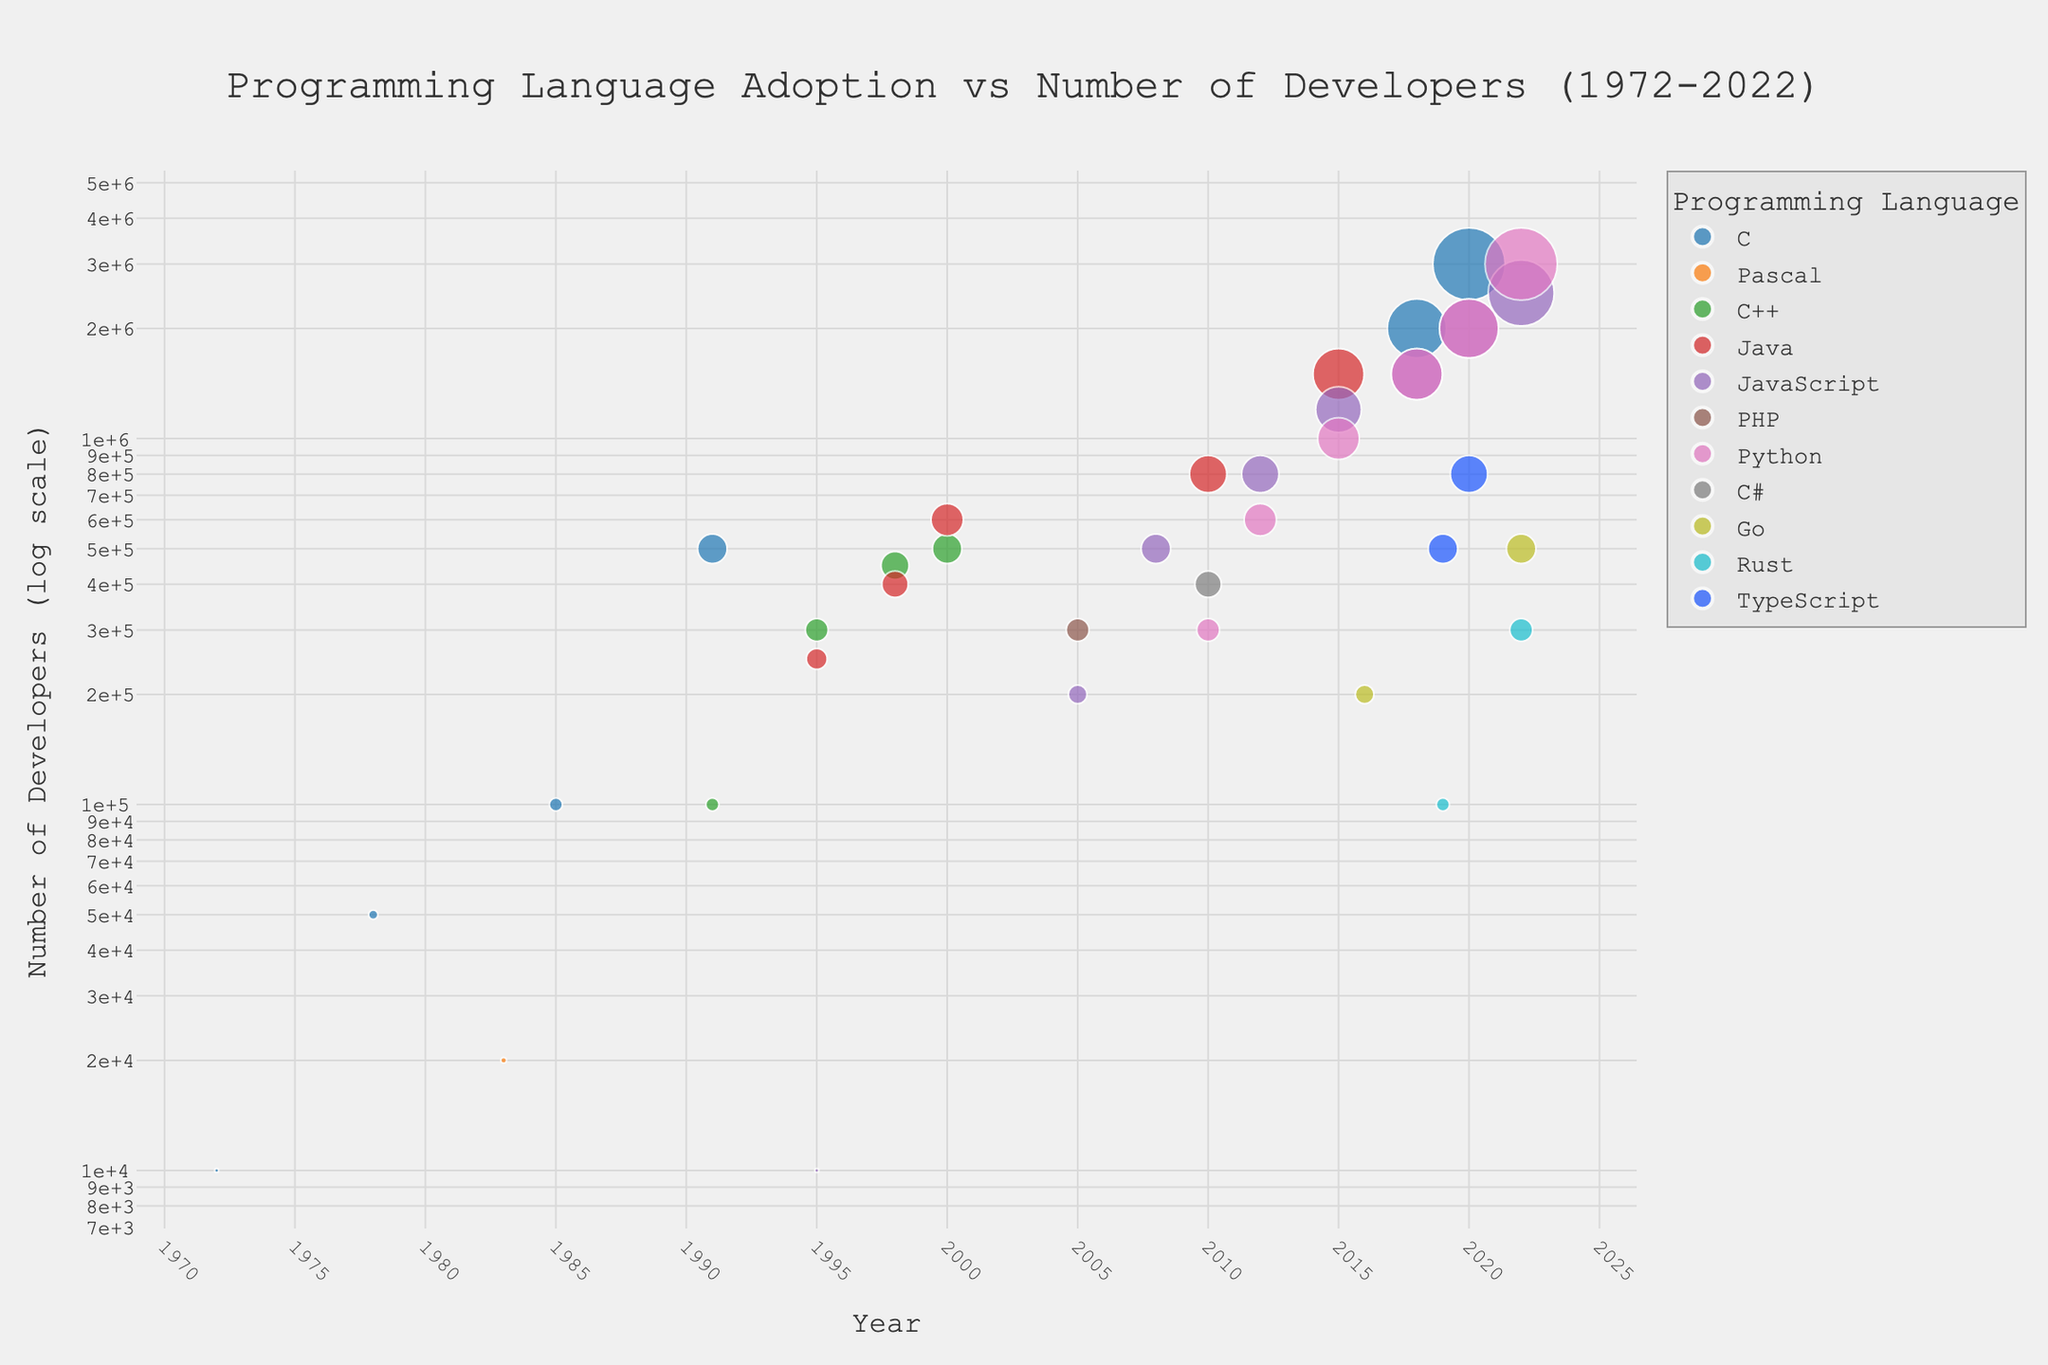what is the title of the figure? The title is usually displayed at the top of the figure, centered and larger in font size compared to other text elements.
Answer: Programming Language Adoption vs Number of Developers (1972-2022) Which programming language had the largest number of developers in 2022? In 2022, locate the right side of the x-axis, and then look for the highest point on the y-axis, which corresponds to the largest number of developers. The label indicates it is Python.
Answer: Python How many developers used JavaScript in 2015? Find the point marked "2015" on the x-axis, look for the "JavaScript" data point in that year, and read the corresponding value on the y-axis. This value represents the number of developers.
Answer: 1,200,000 Which year saw the highest adoption rate for C? Locate the points on the plot specifically for the "C" language, then find the highest point on the y-axis and note its corresponding year on the x-axis.
Answer: 2020 Compare the number of developers for Java and Python in 2018, which had more? Identify the points for Java and Python in 2018. Compare their positions on the y-axis. Python has a higher position than Java, indicating it had more developers.
Answer: Python In which year did C++ first appear in the dataset, and what was the number of developers? Locate the first instance of "C++" on the x-axis and check the corresponding y-axis value for that year.
Answer: 1991, 100,000 What is the general trend for Python's adoption from 2010 to 2022? Trace the points for Python from 2010 to 2022. Observe whether these points move upwards or downwards on the y-axis. The trend shows an upward movement, indicating increasing adoption.
Answer: Increasing Which language had a sharp increase in the number of developers from 1995 to 2000? Look at the points from 1995 to 2000 for each language. Find the one with the steepest rise on the y-axis between these years. Java shows a notable sharp increase.
Answer: Java How many languages had more than 1 million developers in 2020? Locate the "2020" points on the x-axis and count the number of points with y-axis values exceeding 1 million. Three languages meet this criterion.
Answer: 3 If we only consider the data points in 2018, which language grew the most from its previous appearance? Compare the points in 2018 with their corresponding previous years, finding the language with the maximum increase on the y-axis. Python shows the most significant growth from its previous point in 2015.
Answer: Python 